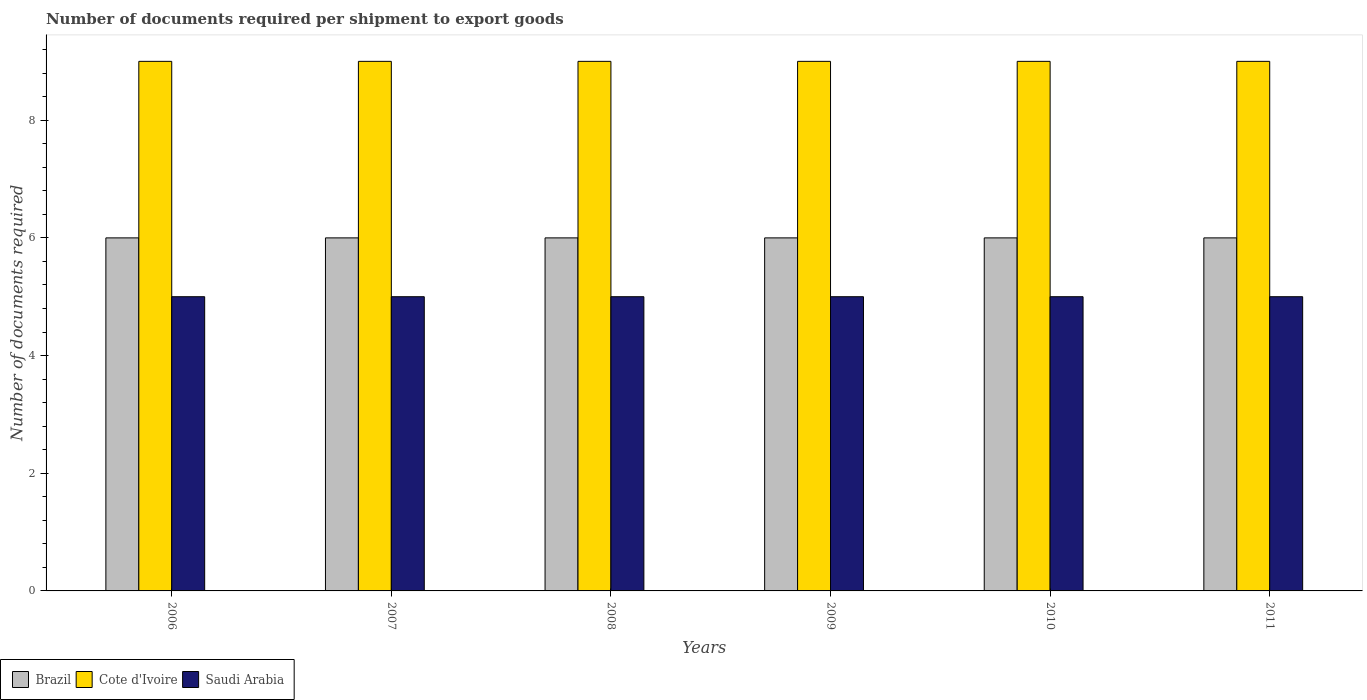How many different coloured bars are there?
Your answer should be compact. 3. Are the number of bars on each tick of the X-axis equal?
Provide a short and direct response. Yes. What is the number of documents required per shipment to export goods in Cote d'Ivoire in 2008?
Give a very brief answer. 9. Across all years, what is the maximum number of documents required per shipment to export goods in Saudi Arabia?
Ensure brevity in your answer.  5. Across all years, what is the minimum number of documents required per shipment to export goods in Saudi Arabia?
Your answer should be very brief. 5. In which year was the number of documents required per shipment to export goods in Brazil maximum?
Your response must be concise. 2006. In which year was the number of documents required per shipment to export goods in Brazil minimum?
Give a very brief answer. 2006. What is the total number of documents required per shipment to export goods in Brazil in the graph?
Ensure brevity in your answer.  36. What is the difference between the number of documents required per shipment to export goods in Saudi Arabia in 2010 and the number of documents required per shipment to export goods in Cote d'Ivoire in 2009?
Provide a succinct answer. -4. What is the average number of documents required per shipment to export goods in Saudi Arabia per year?
Ensure brevity in your answer.  5. In the year 2008, what is the difference between the number of documents required per shipment to export goods in Cote d'Ivoire and number of documents required per shipment to export goods in Saudi Arabia?
Ensure brevity in your answer.  4. In how many years, is the number of documents required per shipment to export goods in Saudi Arabia greater than 8?
Keep it short and to the point. 0. Is the number of documents required per shipment to export goods in Brazil in 2006 less than that in 2010?
Make the answer very short. No. Is the difference between the number of documents required per shipment to export goods in Cote d'Ivoire in 2007 and 2010 greater than the difference between the number of documents required per shipment to export goods in Saudi Arabia in 2007 and 2010?
Offer a terse response. No. In how many years, is the number of documents required per shipment to export goods in Cote d'Ivoire greater than the average number of documents required per shipment to export goods in Cote d'Ivoire taken over all years?
Offer a terse response. 0. What does the 3rd bar from the left in 2010 represents?
Keep it short and to the point. Saudi Arabia. What does the 2nd bar from the right in 2009 represents?
Give a very brief answer. Cote d'Ivoire. Is it the case that in every year, the sum of the number of documents required per shipment to export goods in Brazil and number of documents required per shipment to export goods in Cote d'Ivoire is greater than the number of documents required per shipment to export goods in Saudi Arabia?
Make the answer very short. Yes. How many bars are there?
Make the answer very short. 18. What is the difference between two consecutive major ticks on the Y-axis?
Your answer should be very brief. 2. Are the values on the major ticks of Y-axis written in scientific E-notation?
Offer a very short reply. No. Does the graph contain any zero values?
Provide a short and direct response. No. Does the graph contain grids?
Offer a terse response. No. How many legend labels are there?
Your response must be concise. 3. How are the legend labels stacked?
Your answer should be compact. Horizontal. What is the title of the graph?
Give a very brief answer. Number of documents required per shipment to export goods. What is the label or title of the Y-axis?
Make the answer very short. Number of documents required. What is the Number of documents required in Brazil in 2006?
Give a very brief answer. 6. What is the Number of documents required in Cote d'Ivoire in 2006?
Your response must be concise. 9. What is the Number of documents required in Cote d'Ivoire in 2007?
Ensure brevity in your answer.  9. What is the Number of documents required of Cote d'Ivoire in 2009?
Offer a terse response. 9. What is the Number of documents required of Cote d'Ivoire in 2010?
Make the answer very short. 9. What is the Number of documents required in Cote d'Ivoire in 2011?
Ensure brevity in your answer.  9. What is the Number of documents required in Saudi Arabia in 2011?
Make the answer very short. 5. Across all years, what is the maximum Number of documents required of Cote d'Ivoire?
Provide a succinct answer. 9. Across all years, what is the minimum Number of documents required of Brazil?
Provide a succinct answer. 6. Across all years, what is the minimum Number of documents required of Cote d'Ivoire?
Provide a short and direct response. 9. What is the total Number of documents required in Brazil in the graph?
Provide a succinct answer. 36. What is the total Number of documents required in Saudi Arabia in the graph?
Provide a short and direct response. 30. What is the difference between the Number of documents required in Saudi Arabia in 2006 and that in 2007?
Your answer should be very brief. 0. What is the difference between the Number of documents required in Brazil in 2006 and that in 2008?
Keep it short and to the point. 0. What is the difference between the Number of documents required of Cote d'Ivoire in 2006 and that in 2008?
Offer a very short reply. 0. What is the difference between the Number of documents required of Brazil in 2006 and that in 2009?
Ensure brevity in your answer.  0. What is the difference between the Number of documents required in Saudi Arabia in 2006 and that in 2009?
Provide a succinct answer. 0. What is the difference between the Number of documents required in Saudi Arabia in 2006 and that in 2010?
Your response must be concise. 0. What is the difference between the Number of documents required in Saudi Arabia in 2007 and that in 2008?
Your answer should be compact. 0. What is the difference between the Number of documents required in Brazil in 2007 and that in 2009?
Give a very brief answer. 0. What is the difference between the Number of documents required in Brazil in 2007 and that in 2011?
Offer a terse response. 0. What is the difference between the Number of documents required in Saudi Arabia in 2008 and that in 2009?
Offer a terse response. 0. What is the difference between the Number of documents required in Cote d'Ivoire in 2008 and that in 2010?
Give a very brief answer. 0. What is the difference between the Number of documents required of Saudi Arabia in 2008 and that in 2011?
Keep it short and to the point. 0. What is the difference between the Number of documents required in Brazil in 2009 and that in 2010?
Provide a succinct answer. 0. What is the difference between the Number of documents required of Saudi Arabia in 2009 and that in 2010?
Ensure brevity in your answer.  0. What is the difference between the Number of documents required in Cote d'Ivoire in 2009 and that in 2011?
Your answer should be very brief. 0. What is the difference between the Number of documents required in Brazil in 2010 and that in 2011?
Your response must be concise. 0. What is the difference between the Number of documents required of Saudi Arabia in 2010 and that in 2011?
Provide a succinct answer. 0. What is the difference between the Number of documents required of Brazil in 2006 and the Number of documents required of Cote d'Ivoire in 2007?
Ensure brevity in your answer.  -3. What is the difference between the Number of documents required of Brazil in 2006 and the Number of documents required of Cote d'Ivoire in 2008?
Make the answer very short. -3. What is the difference between the Number of documents required in Brazil in 2006 and the Number of documents required in Saudi Arabia in 2008?
Keep it short and to the point. 1. What is the difference between the Number of documents required in Cote d'Ivoire in 2006 and the Number of documents required in Saudi Arabia in 2008?
Provide a succinct answer. 4. What is the difference between the Number of documents required in Brazil in 2006 and the Number of documents required in Cote d'Ivoire in 2009?
Provide a short and direct response. -3. What is the difference between the Number of documents required in Brazil in 2006 and the Number of documents required in Saudi Arabia in 2009?
Offer a very short reply. 1. What is the difference between the Number of documents required of Brazil in 2006 and the Number of documents required of Saudi Arabia in 2010?
Provide a short and direct response. 1. What is the difference between the Number of documents required in Brazil in 2006 and the Number of documents required in Cote d'Ivoire in 2011?
Your response must be concise. -3. What is the difference between the Number of documents required of Brazil in 2006 and the Number of documents required of Saudi Arabia in 2011?
Offer a very short reply. 1. What is the difference between the Number of documents required in Brazil in 2007 and the Number of documents required in Cote d'Ivoire in 2008?
Make the answer very short. -3. What is the difference between the Number of documents required in Brazil in 2007 and the Number of documents required in Cote d'Ivoire in 2010?
Your response must be concise. -3. What is the difference between the Number of documents required in Brazil in 2007 and the Number of documents required in Saudi Arabia in 2010?
Offer a very short reply. 1. What is the difference between the Number of documents required in Cote d'Ivoire in 2007 and the Number of documents required in Saudi Arabia in 2010?
Your response must be concise. 4. What is the difference between the Number of documents required in Brazil in 2007 and the Number of documents required in Cote d'Ivoire in 2011?
Offer a terse response. -3. What is the difference between the Number of documents required in Brazil in 2007 and the Number of documents required in Saudi Arabia in 2011?
Your response must be concise. 1. What is the difference between the Number of documents required of Brazil in 2008 and the Number of documents required of Cote d'Ivoire in 2009?
Keep it short and to the point. -3. What is the difference between the Number of documents required of Brazil in 2008 and the Number of documents required of Saudi Arabia in 2009?
Keep it short and to the point. 1. What is the difference between the Number of documents required in Brazil in 2008 and the Number of documents required in Cote d'Ivoire in 2010?
Your answer should be compact. -3. What is the difference between the Number of documents required of Brazil in 2008 and the Number of documents required of Saudi Arabia in 2010?
Offer a very short reply. 1. What is the difference between the Number of documents required of Cote d'Ivoire in 2008 and the Number of documents required of Saudi Arabia in 2011?
Your answer should be very brief. 4. What is the difference between the Number of documents required of Brazil in 2009 and the Number of documents required of Saudi Arabia in 2010?
Keep it short and to the point. 1. What is the difference between the Number of documents required of Cote d'Ivoire in 2009 and the Number of documents required of Saudi Arabia in 2010?
Provide a succinct answer. 4. What is the difference between the Number of documents required in Brazil in 2009 and the Number of documents required in Cote d'Ivoire in 2011?
Provide a short and direct response. -3. What is the difference between the Number of documents required of Cote d'Ivoire in 2009 and the Number of documents required of Saudi Arabia in 2011?
Keep it short and to the point. 4. What is the difference between the Number of documents required of Cote d'Ivoire in 2010 and the Number of documents required of Saudi Arabia in 2011?
Offer a very short reply. 4. What is the average Number of documents required of Brazil per year?
Provide a short and direct response. 6. In the year 2006, what is the difference between the Number of documents required in Brazil and Number of documents required in Saudi Arabia?
Ensure brevity in your answer.  1. In the year 2006, what is the difference between the Number of documents required of Cote d'Ivoire and Number of documents required of Saudi Arabia?
Provide a succinct answer. 4. In the year 2007, what is the difference between the Number of documents required in Brazil and Number of documents required in Saudi Arabia?
Keep it short and to the point. 1. In the year 2008, what is the difference between the Number of documents required in Brazil and Number of documents required in Cote d'Ivoire?
Provide a succinct answer. -3. In the year 2008, what is the difference between the Number of documents required of Brazil and Number of documents required of Saudi Arabia?
Your response must be concise. 1. In the year 2010, what is the difference between the Number of documents required in Brazil and Number of documents required in Cote d'Ivoire?
Offer a terse response. -3. In the year 2011, what is the difference between the Number of documents required of Brazil and Number of documents required of Cote d'Ivoire?
Give a very brief answer. -3. In the year 2011, what is the difference between the Number of documents required of Brazil and Number of documents required of Saudi Arabia?
Offer a terse response. 1. What is the ratio of the Number of documents required in Saudi Arabia in 2006 to that in 2007?
Your answer should be very brief. 1. What is the ratio of the Number of documents required in Brazil in 2006 to that in 2008?
Provide a short and direct response. 1. What is the ratio of the Number of documents required in Saudi Arabia in 2006 to that in 2008?
Provide a succinct answer. 1. What is the ratio of the Number of documents required in Saudi Arabia in 2006 to that in 2009?
Ensure brevity in your answer.  1. What is the ratio of the Number of documents required of Brazil in 2006 to that in 2010?
Give a very brief answer. 1. What is the ratio of the Number of documents required of Cote d'Ivoire in 2006 to that in 2010?
Provide a short and direct response. 1. What is the ratio of the Number of documents required of Saudi Arabia in 2006 to that in 2011?
Your answer should be compact. 1. What is the ratio of the Number of documents required in Brazil in 2007 to that in 2008?
Keep it short and to the point. 1. What is the ratio of the Number of documents required of Brazil in 2007 to that in 2009?
Give a very brief answer. 1. What is the ratio of the Number of documents required of Brazil in 2007 to that in 2010?
Your answer should be very brief. 1. What is the ratio of the Number of documents required in Cote d'Ivoire in 2007 to that in 2011?
Give a very brief answer. 1. What is the ratio of the Number of documents required of Saudi Arabia in 2007 to that in 2011?
Provide a succinct answer. 1. What is the ratio of the Number of documents required of Cote d'Ivoire in 2008 to that in 2009?
Offer a terse response. 1. What is the ratio of the Number of documents required in Saudi Arabia in 2008 to that in 2009?
Keep it short and to the point. 1. What is the ratio of the Number of documents required in Brazil in 2008 to that in 2010?
Keep it short and to the point. 1. What is the ratio of the Number of documents required in Cote d'Ivoire in 2008 to that in 2010?
Keep it short and to the point. 1. What is the ratio of the Number of documents required of Saudi Arabia in 2008 to that in 2011?
Provide a short and direct response. 1. What is the ratio of the Number of documents required in Brazil in 2009 to that in 2010?
Keep it short and to the point. 1. What is the ratio of the Number of documents required in Saudi Arabia in 2009 to that in 2011?
Give a very brief answer. 1. What is the ratio of the Number of documents required in Cote d'Ivoire in 2010 to that in 2011?
Offer a terse response. 1. What is the ratio of the Number of documents required in Saudi Arabia in 2010 to that in 2011?
Provide a succinct answer. 1. What is the difference between the highest and the second highest Number of documents required in Cote d'Ivoire?
Make the answer very short. 0. What is the difference between the highest and the second highest Number of documents required of Saudi Arabia?
Offer a very short reply. 0. What is the difference between the highest and the lowest Number of documents required of Brazil?
Your answer should be very brief. 0. What is the difference between the highest and the lowest Number of documents required in Saudi Arabia?
Keep it short and to the point. 0. 